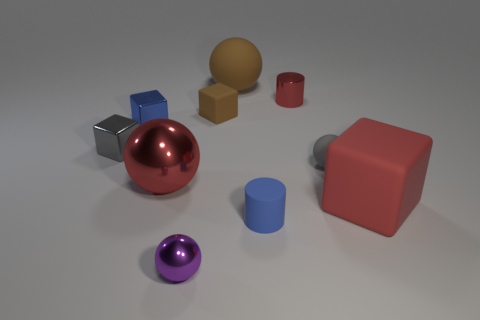There is a metallic block that is the same color as the tiny matte sphere; what size is it?
Give a very brief answer. Small. There is a cube that is the same color as the big metal sphere; what is its material?
Give a very brief answer. Rubber. Are there any tiny shiny cylinders that have the same color as the large block?
Offer a terse response. Yes. Are there any gray balls made of the same material as the tiny brown cube?
Ensure brevity in your answer.  Yes. Is the color of the small shiny cylinder the same as the big shiny ball?
Provide a succinct answer. Yes. There is a big thing that is in front of the small brown cube and right of the purple shiny sphere; what material is it made of?
Make the answer very short. Rubber. What is the color of the big metal sphere?
Give a very brief answer. Red. What number of blue things are the same shape as the tiny red metal thing?
Make the answer very short. 1. Is the red object that is on the left side of the brown matte sphere made of the same material as the small cylinder that is behind the gray block?
Give a very brief answer. Yes. There is a metallic ball that is behind the matte block right of the brown matte ball; how big is it?
Provide a short and direct response. Large. 